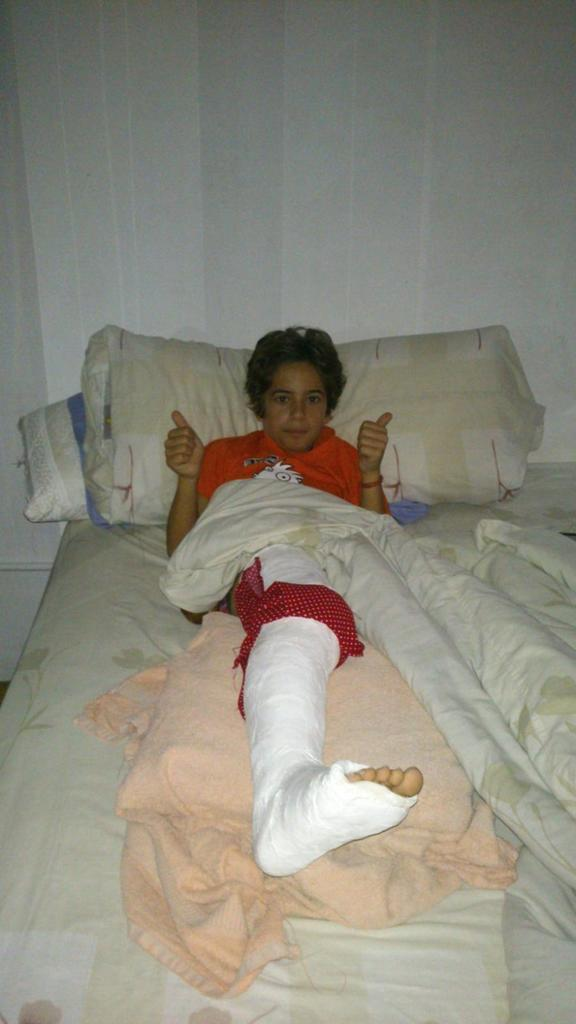What piece of furniture is present in the image? There is a bed in the image. What is placed on the bed? There are pillows on the bed. Is there anyone on the bed? Yes, there is a person on the bed. Can you describe the person's appearance or condition? The person has a bandage on their leg. What else is on the bed besides the pillows and person? There is a bed sheet on the bed. How far away is the nearest popcorn machine from the bed in the image? There is no popcorn machine present in the image, so it is not possible to determine its distance from the bed. 